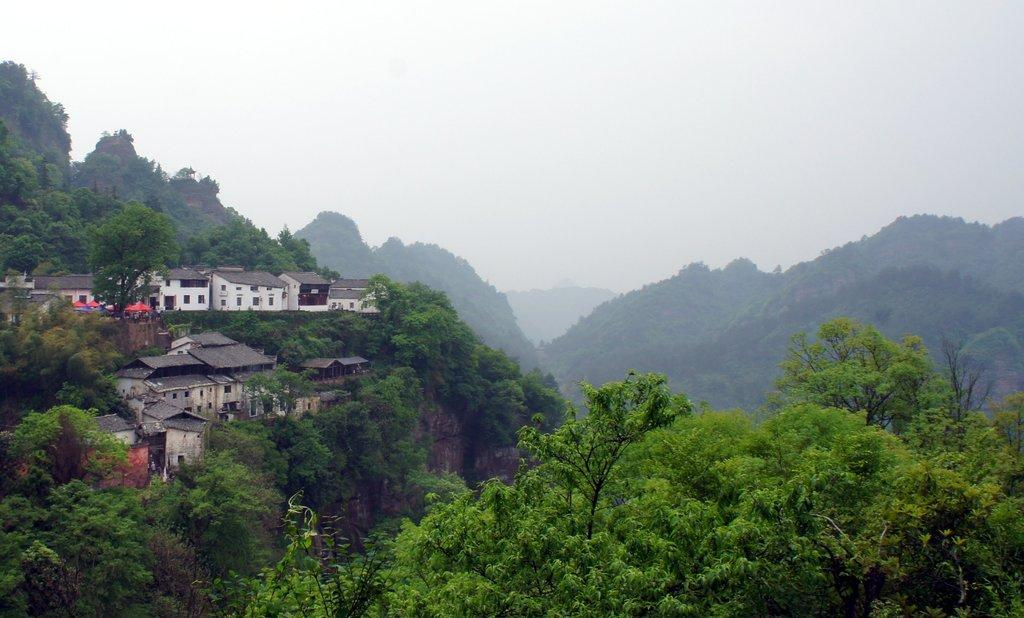What type of structures can be seen on the hill in the image? There are houses on a hill in the image. What natural features are visible in the image? There are mountains and trees in the image. What type of vegetation can be seen in the image? There are plants in the image. What advice does the queen give to the committee in the image? There is no queen or committee present in the image; it features houses on a hill, mountains, trees, and plants. 